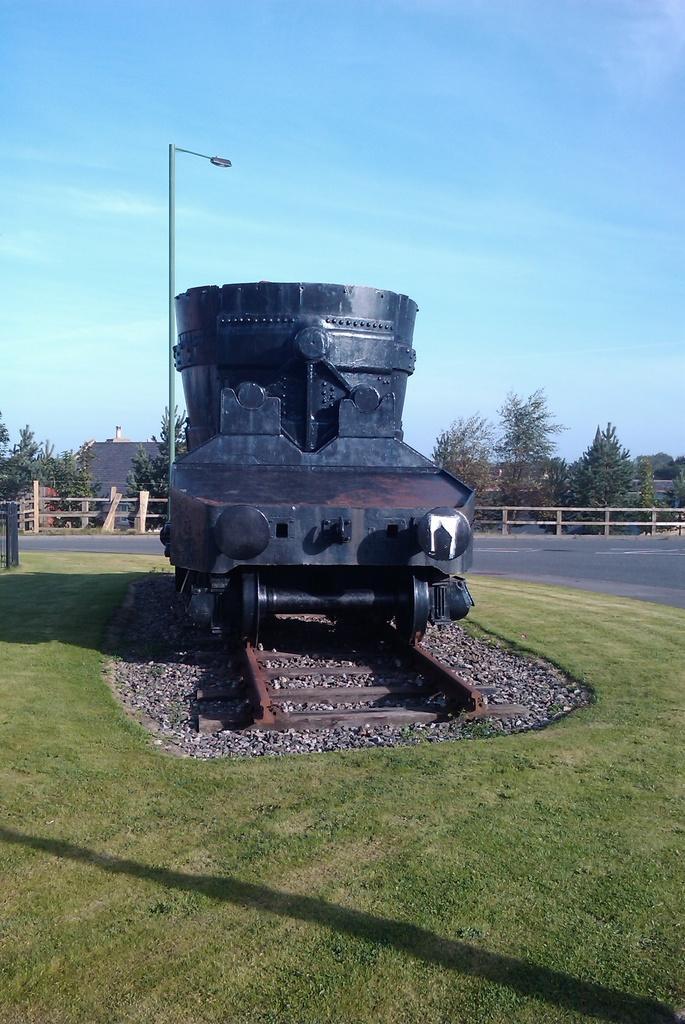In one or two sentences, can you explain what this image depicts? In this image we can see sculpture placed on the ground. In the background we can see wooden grill, trees, buildings, street pole, street light and sky with clouds. 